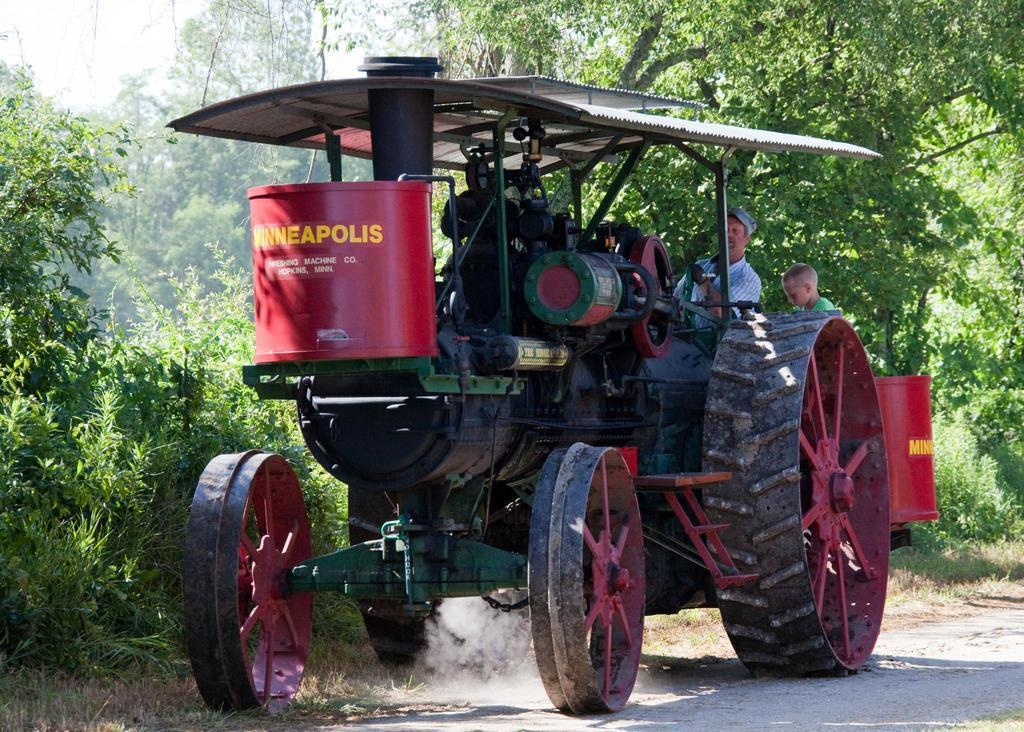Can you describe this image briefly? In this image we can see two persons, a person is driving a vehicle on the road and there are few trees and the sky in the background. 